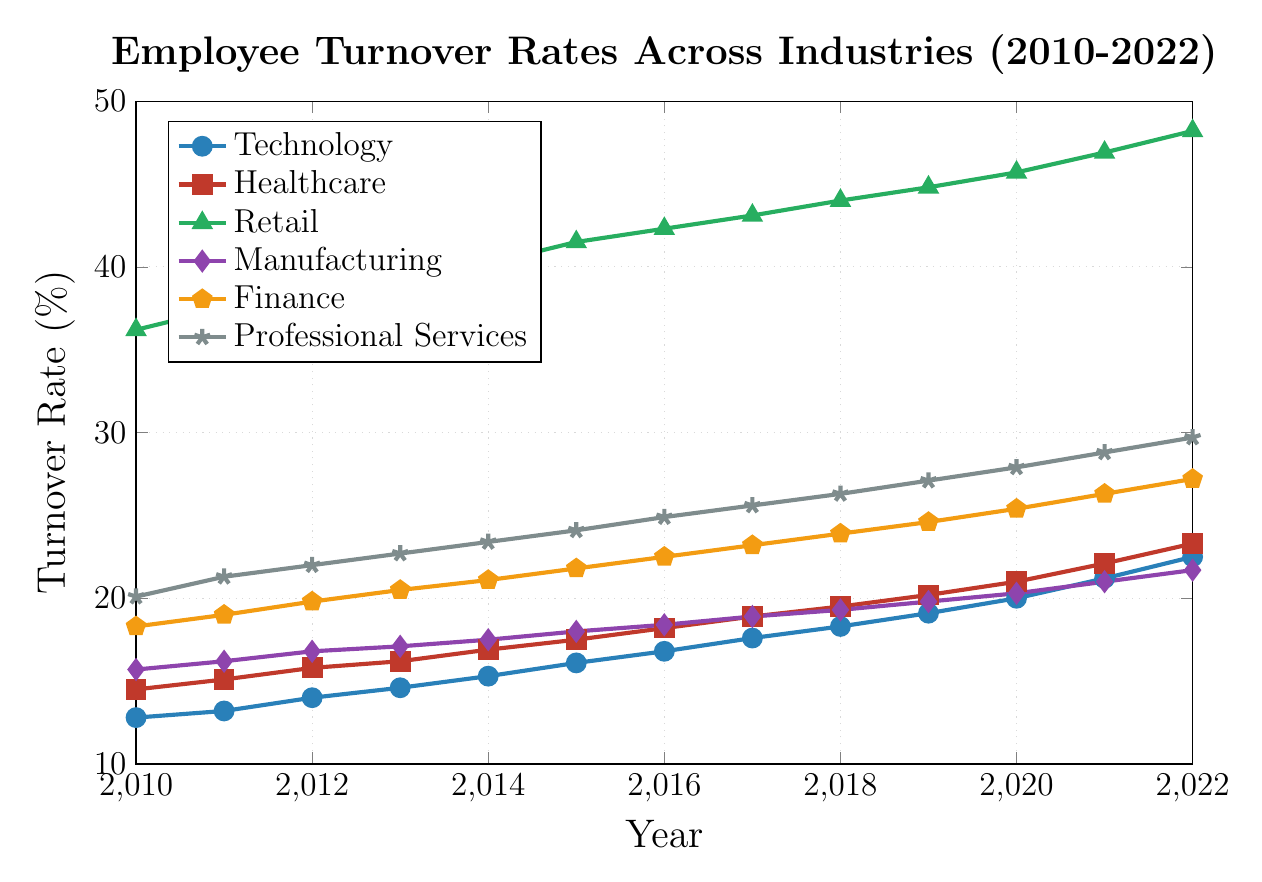Which industry has the highest turnover rate in 2022? The Retail industry has the highest turnover rate in 2022. This can be identified by observing the data point of each industry at the year 2022.
Answer: Retail How did the turnover rate in Healthcare change from 2010 to 2022? The turnover rate in Healthcare increased from 14.5% in 2010 to 23.3% in 2022, which can be seen by comparing the first data point to the last data point in the Healthcare curve.
Answer: Increased by 8.8% Which industry had a lower turnover rate than Manufacturing in 2016? In 2016, Technology (16.8%) and Healthcare (18.2%) both had lower turnover rates compared to Manufacturing (18.4%).
Answer: Technology, Healthcare What is the average turnover rate for the Finance industry between 2010 and 2022? Sum all the turnover rates for Finance from 2010 to 2022 (18.3 + 19.0 + 19.8 + 20.5 + 21.1 + 21.8 + 22.5 + 23.2 + 23.9 + 24.6 + 25.4 + 26.3 + 27.2 = 273.6), and then divide by the number of years (273.6 / 13).
Answer: 21.05% Which industry showed the most consistent increase in turnover rate over the years? By observing the slopes of all industries' lines from 2010 to 2022, both Retail and Professional Services show consistent increases without any dips. However, the slopes for Retail are more uniform than for Professional Services, indicating steadier increases.
Answer: Retail Compare the turnover rate between Technology and Professional Services in 2019. Which was higher? The turnover rate for Technology in 2019 was 19.1%, and for Professional Services, it was 27.1%. By comparing these values, Professional Services had a higher turnover rate in 2019.
Answer: Professional Services What was the turnover rate difference between the highest and lowest industries in 2014? In 2014, the highest turnover rate was in Retail at 40.2%, and the lowest was in Technology at 15.3%. The difference is (40.2 - 15.3).
Answer: 24.9% Was there any year when the turnover rate of Manufacturing was higher than that of Finance? By comparing the turnover rates of Manufacturing and Finance for each year from 2010 to 2022, we can see that for every year, the turnover rate of Finance is higher than that of Manufacturing.
Answer: No Which industry saw the smallest increase in turnover rate between 2010 and 2022? By calculating the increase for each industry from 2010 to 2022, Healthcare's increase is the smallest (23.3 - 14.5 = 8.8), compared to other industries.
Answer: Healthcare How did the turnover rate for Professional Services change from 2014 to 2021? The turnover rate for Professional Services increased from 23.4% in 2014 to 28.8% in 2021, which is an increase of (28.8 - 23.4).
Answer: Increased by 5.4% 